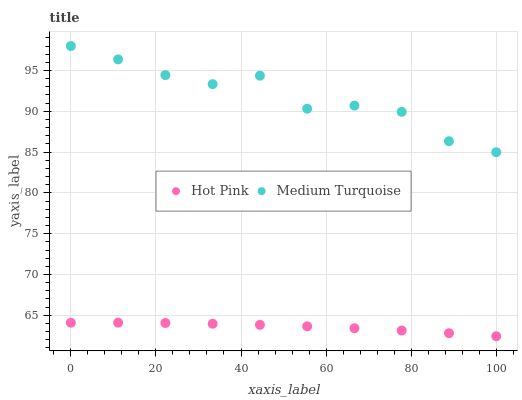Does Hot Pink have the minimum area under the curve?
Answer yes or no. Yes. Does Medium Turquoise have the maximum area under the curve?
Answer yes or no. Yes. Does Medium Turquoise have the minimum area under the curve?
Answer yes or no. No. Is Hot Pink the smoothest?
Answer yes or no. Yes. Is Medium Turquoise the roughest?
Answer yes or no. Yes. Is Medium Turquoise the smoothest?
Answer yes or no. No. Does Hot Pink have the lowest value?
Answer yes or no. Yes. Does Medium Turquoise have the lowest value?
Answer yes or no. No. Does Medium Turquoise have the highest value?
Answer yes or no. Yes. Is Hot Pink less than Medium Turquoise?
Answer yes or no. Yes. Is Medium Turquoise greater than Hot Pink?
Answer yes or no. Yes. Does Hot Pink intersect Medium Turquoise?
Answer yes or no. No. 